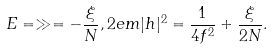<formula> <loc_0><loc_0><loc_500><loc_500>E = \gg = - \frac { \xi } { N } , 2 e m | h | ^ { 2 } = \frac { 1 } { 4 f ^ { 2 } } + \frac { \xi } { 2 N } .</formula> 